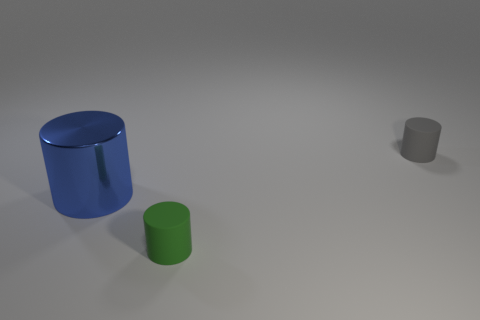Is there anything else that has the same material as the big object?
Your answer should be very brief. No. How many gray cylinders are to the right of the blue cylinder?
Your response must be concise. 1. What is the material of the big blue object?
Offer a very short reply. Metal. What is the color of the tiny rubber cylinder that is to the right of the small rubber cylinder in front of the tiny rubber thing that is behind the small green cylinder?
Offer a very short reply. Gray. How many gray matte things have the same size as the shiny object?
Provide a succinct answer. 0. There is a cylinder that is behind the big blue shiny thing; what is its color?
Your answer should be very brief. Gray. What number of other things are the same size as the gray thing?
Offer a very short reply. 1. There is a cylinder that is both on the left side of the gray matte thing and behind the small green rubber object; how big is it?
Offer a terse response. Large. Does the big shiny thing have the same color as the matte cylinder in front of the gray thing?
Provide a short and direct response. No. Is there a tiny green object of the same shape as the small gray matte thing?
Offer a very short reply. Yes. 